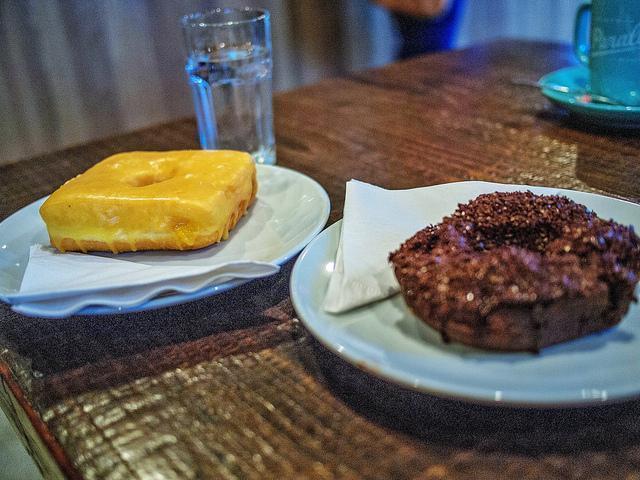What material would the plates be made of?
Select the correct answer and articulate reasoning with the following format: 'Answer: answer
Rationale: rationale.'
Options: Ceramic, wood, iron, carpet. Answer: ceramic.
Rationale: The plates are hard and shiny. 